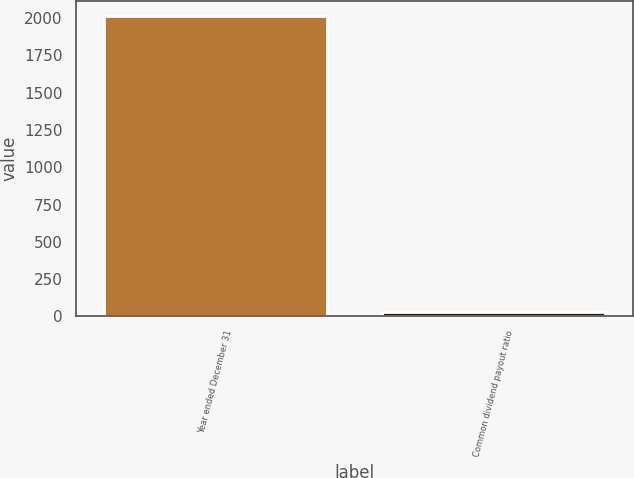<chart> <loc_0><loc_0><loc_500><loc_500><bar_chart><fcel>Year ended December 31<fcel>Common dividend payout ratio<nl><fcel>2014<fcel>29<nl></chart> 